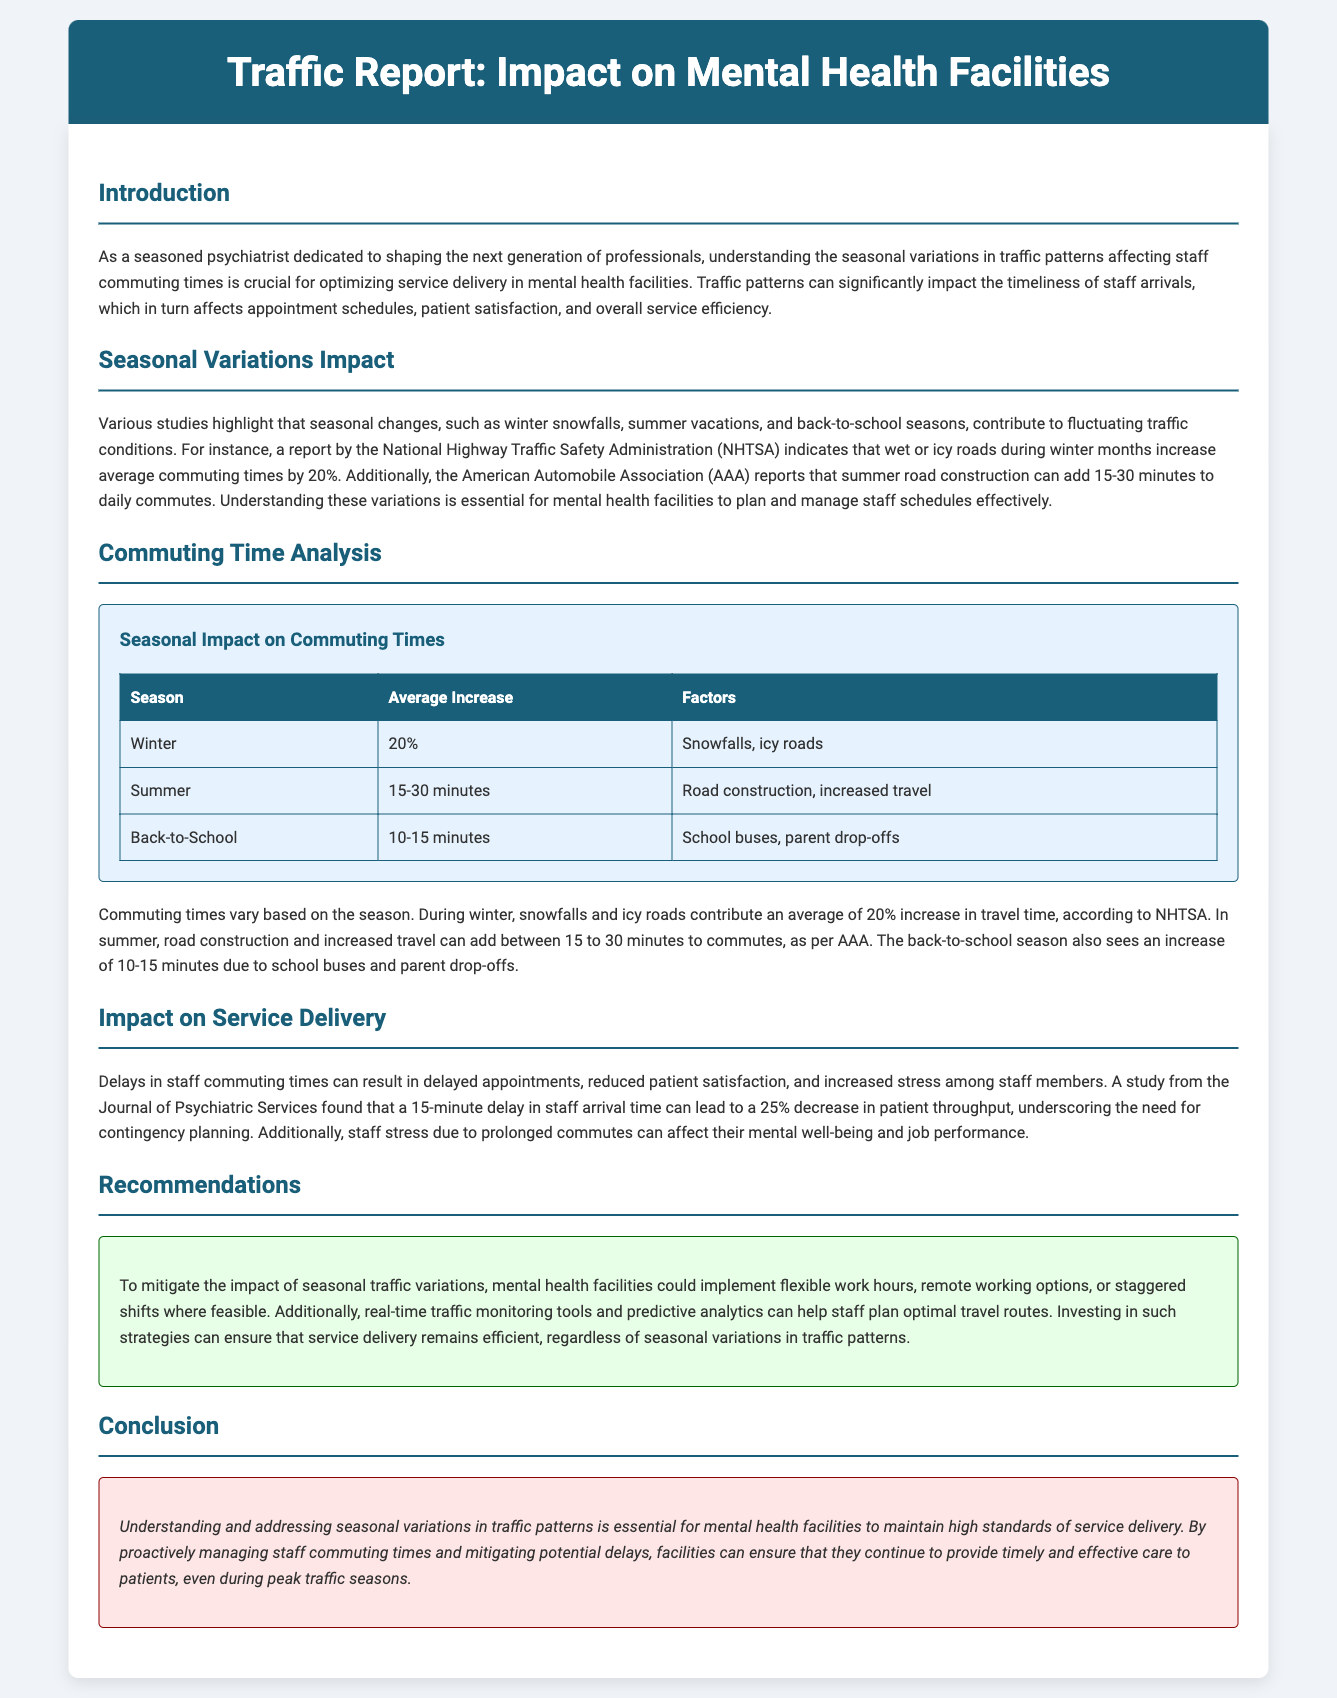What is the focus of the traffic report? The traffic report focuses on understanding seasonal variations in traffic patterns affecting staff commuting times and their impact on service delivery in mental health facilities.
Answer: Seasonal variations in traffic patterns What seasonal change increases commuting time by 20%? The document mentions that snowfalls and icy roads contribute to a 20% increase in commuting time during winter.
Answer: Winter What factors contribute to increased commuting time in summer? Road construction and increased travel are the contributing factors to increased commuting time in the summer.
Answer: Road construction, increased travel What is the average increase in commuting time during the back-to-school season? The back-to-school season adds an average increase of 10-15 minutes to commuting times.
Answer: 10-15 minutes What effect does a 15-minute delay have on patient throughput? A 15-minute delay in staff arrival time can lead to a 25% decrease in patient throughput, according to the document.
Answer: 25% What measures can mental health facilities take to mitigate traffic impact? The report suggests implementing flexible work hours, remote options, or staggered shifts to mitigate the impact of seasonal traffic variations.
Answer: Flexible work hours, remote options, staggered shifts What percentage increase is reported for commuting time in winter? The report indicates a 20% increase in commuting time during winter due to traffic conditions.
Answer: 20% Which organization reported that summer road construction can add minutes to daily commutes? The American Automobile Association (AAA) reported that summer road construction can add 15-30 minutes to daily commutes.
Answer: American Automobile Association (AAA) 